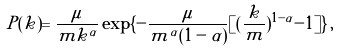<formula> <loc_0><loc_0><loc_500><loc_500>P ( k ) = \frac { \mu } { m k ^ { \alpha } } \exp \{ - \frac { \mu } { m ^ { \alpha } ( 1 - \alpha ) } [ ( \frac { k } { m } ) ^ { 1 - \alpha } - 1 ] \} \, ,</formula> 